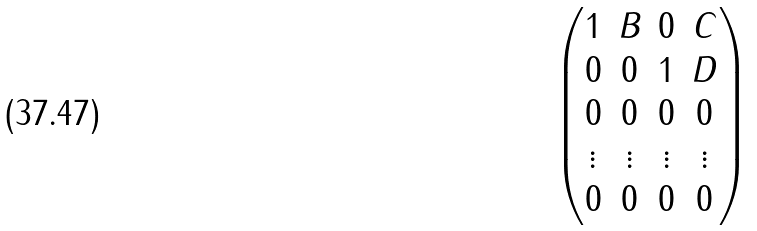<formula> <loc_0><loc_0><loc_500><loc_500>\begin{pmatrix} 1 & B & 0 & C \\ 0 & 0 & 1 & D \\ 0 & 0 & 0 & 0 \\ \vdots & \vdots & \vdots & \vdots \\ 0 & 0 & 0 & 0 \\ \end{pmatrix}</formula> 